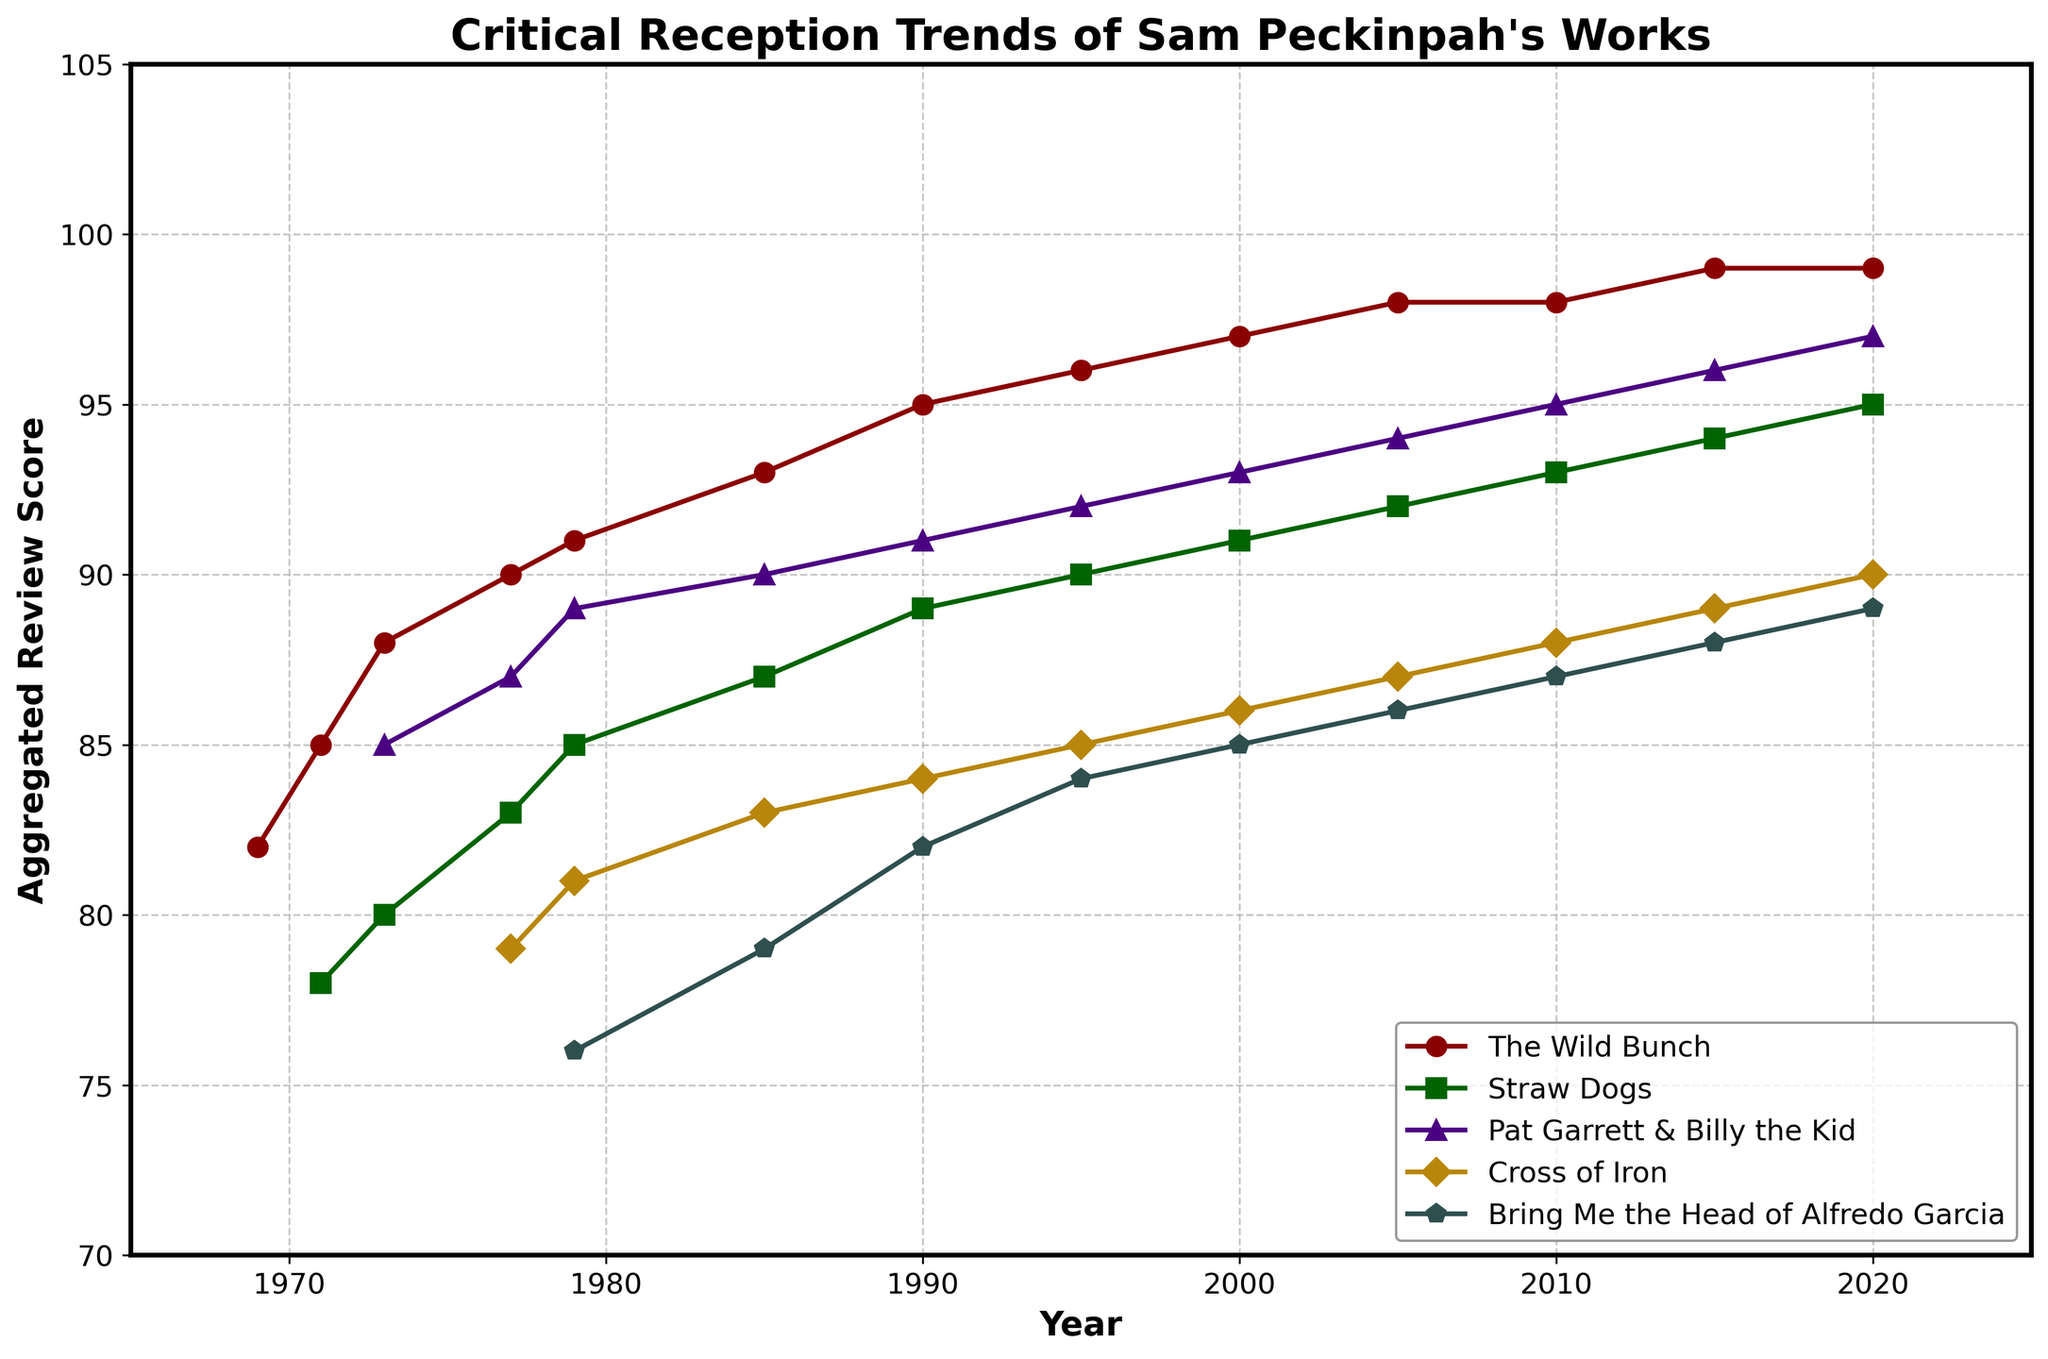What's the trend of the review scores for "The Wild Bunch" from 1969 to 2020? By observing the line representing "The Wild Bunch," you can see that the score starts at 82 in 1969 and increases continuously over the years, reaching 99 by 2020.
Answer: Increasing Which film had the lowest aggregated review score in 1979? By looking at the values for each film in 1979, "Bring Me the Head of Alfredo Garcia" has the lowest score of 76.
Answer: Bring Me the Head of Alfredo Garcia How many points did "Cross of Iron" increase from its initial score to 2020? "Cross of Iron" starts with a score of 79 in 1977 and increases to 90 by 2020. The difference is 90 - 79 = 11.
Answer: 11 Which film had the most consistent increase in review scores over the years? All films show an increasing trend, but "Straw Dogs" and "Cross of Iron" have more steady, less fluctuating increases compared to the others.
Answer: Straw Dogs In which year did "Pat Garrett & Billy the Kid" surpass a score of 90? By observing the trend line for "Pat Garrett & Billy the Kid," it surpassed a score of 90 in 1990 with a rating of 91.
Answer: 1990 Which film has the highest review score in 2010? By checking the values for each film in 2010, "The Wild Bunch" has the highest review score of 98.
Answer: The Wild Bunch What is the average review score of "Straw Dogs" from 1971 to 2020? Sum the scores of "Straw Dogs" from all the available years and divide by the number of years (13). The sum is 78+80+83+85+87+89+90+91+92+93+94+95=1108. Divide by 13 to get the average: 1108/13 ≈ 85.23.
Answer: 85.23 How does the review score of "Pat Garrett & Billy the Kid" in 1979 compare to its score in 1990? In 1979, "Pat Garrett & Billy the Kid" had a score of 89, and in 1990 it had a score of 91. 89 < 91, so the score increased.
Answer: Increased Which film had the highest review score growth between 1985 and 2005? For each film, calculate the growth from 1985 to 2005. "The Wild Bunch" grows 98-93=5, "Straw Dogs" grows 92-87=5, "Pat Garrett & Billy the Kid" grows 94-90=4, "Cross of Iron" grows 87-83=4, and "Bring Me the Head of Alfredo Garcia" grows 86-79=7.
Answer: Bring Me the Head of Alfredo Garcia What is the overall trend for Peckinpah’s films' review scores from 1969 to 2020? All the lines representing the films show an upward trend in their scores over the years, indicating that the critical reception of Peckinpah’s works has generally improved.
Answer: Upward trend 